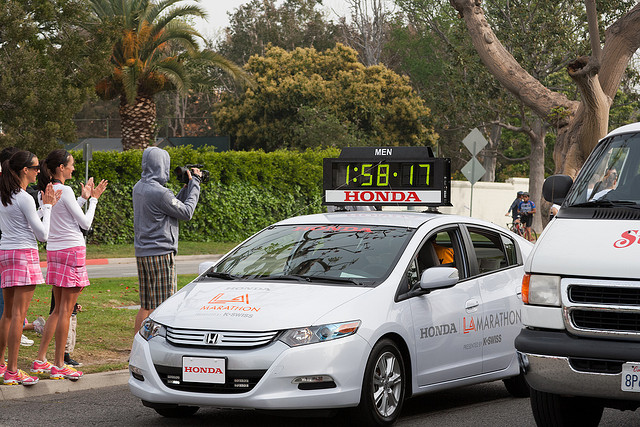Please extract the text content from this image. MEN 1 58 17 HONDA 8P S HONDA LAMARATHON HONDA 